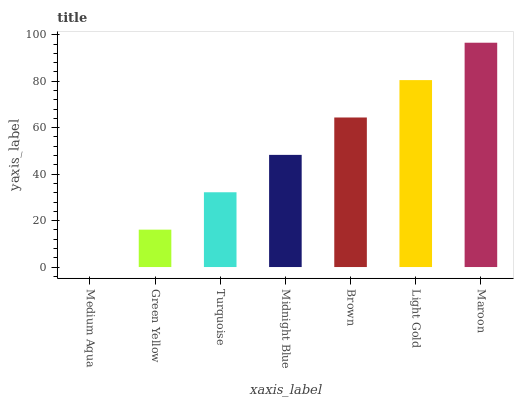Is Green Yellow the minimum?
Answer yes or no. No. Is Green Yellow the maximum?
Answer yes or no. No. Is Green Yellow greater than Medium Aqua?
Answer yes or no. Yes. Is Medium Aqua less than Green Yellow?
Answer yes or no. Yes. Is Medium Aqua greater than Green Yellow?
Answer yes or no. No. Is Green Yellow less than Medium Aqua?
Answer yes or no. No. Is Midnight Blue the high median?
Answer yes or no. Yes. Is Midnight Blue the low median?
Answer yes or no. Yes. Is Maroon the high median?
Answer yes or no. No. Is Medium Aqua the low median?
Answer yes or no. No. 